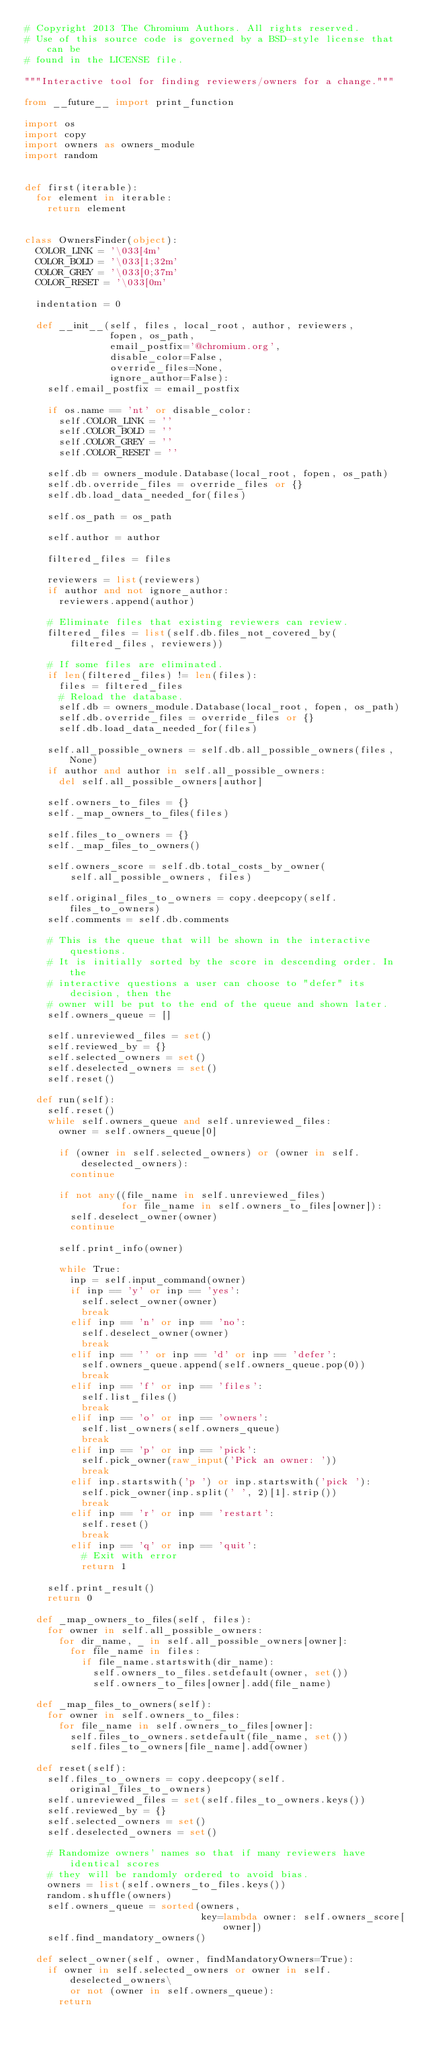Convert code to text. <code><loc_0><loc_0><loc_500><loc_500><_Python_># Copyright 2013 The Chromium Authors. All rights reserved.
# Use of this source code is governed by a BSD-style license that can be
# found in the LICENSE file.

"""Interactive tool for finding reviewers/owners for a change."""

from __future__ import print_function

import os
import copy
import owners as owners_module
import random


def first(iterable):
  for element in iterable:
    return element


class OwnersFinder(object):
  COLOR_LINK = '\033[4m'
  COLOR_BOLD = '\033[1;32m'
  COLOR_GREY = '\033[0;37m'
  COLOR_RESET = '\033[0m'

  indentation = 0

  def __init__(self, files, local_root, author, reviewers,
               fopen, os_path,
               email_postfix='@chromium.org',
               disable_color=False,
               override_files=None,
               ignore_author=False):
    self.email_postfix = email_postfix

    if os.name == 'nt' or disable_color:
      self.COLOR_LINK = ''
      self.COLOR_BOLD = ''
      self.COLOR_GREY = ''
      self.COLOR_RESET = ''

    self.db = owners_module.Database(local_root, fopen, os_path)
    self.db.override_files = override_files or {}
    self.db.load_data_needed_for(files)

    self.os_path = os_path

    self.author = author

    filtered_files = files

    reviewers = list(reviewers)
    if author and not ignore_author:
      reviewers.append(author)

    # Eliminate files that existing reviewers can review.
    filtered_files = list(self.db.files_not_covered_by(
        filtered_files, reviewers))

    # If some files are eliminated.
    if len(filtered_files) != len(files):
      files = filtered_files
      # Reload the database.
      self.db = owners_module.Database(local_root, fopen, os_path)
      self.db.override_files = override_files or {}
      self.db.load_data_needed_for(files)

    self.all_possible_owners = self.db.all_possible_owners(files, None)
    if author and author in self.all_possible_owners:
      del self.all_possible_owners[author]

    self.owners_to_files = {}
    self._map_owners_to_files(files)

    self.files_to_owners = {}
    self._map_files_to_owners()

    self.owners_score = self.db.total_costs_by_owner(
        self.all_possible_owners, files)

    self.original_files_to_owners = copy.deepcopy(self.files_to_owners)
    self.comments = self.db.comments

    # This is the queue that will be shown in the interactive questions.
    # It is initially sorted by the score in descending order. In the
    # interactive questions a user can choose to "defer" its decision, then the
    # owner will be put to the end of the queue and shown later.
    self.owners_queue = []

    self.unreviewed_files = set()
    self.reviewed_by = {}
    self.selected_owners = set()
    self.deselected_owners = set()
    self.reset()

  def run(self):
    self.reset()
    while self.owners_queue and self.unreviewed_files:
      owner = self.owners_queue[0]

      if (owner in self.selected_owners) or (owner in self.deselected_owners):
        continue

      if not any((file_name in self.unreviewed_files)
                 for file_name in self.owners_to_files[owner]):
        self.deselect_owner(owner)
        continue

      self.print_info(owner)

      while True:
        inp = self.input_command(owner)
        if inp == 'y' or inp == 'yes':
          self.select_owner(owner)
          break
        elif inp == 'n' or inp == 'no':
          self.deselect_owner(owner)
          break
        elif inp == '' or inp == 'd' or inp == 'defer':
          self.owners_queue.append(self.owners_queue.pop(0))
          break
        elif inp == 'f' or inp == 'files':
          self.list_files()
          break
        elif inp == 'o' or inp == 'owners':
          self.list_owners(self.owners_queue)
          break
        elif inp == 'p' or inp == 'pick':
          self.pick_owner(raw_input('Pick an owner: '))
          break
        elif inp.startswith('p ') or inp.startswith('pick '):
          self.pick_owner(inp.split(' ', 2)[1].strip())
          break
        elif inp == 'r' or inp == 'restart':
          self.reset()
          break
        elif inp == 'q' or inp == 'quit':
          # Exit with error
          return 1

    self.print_result()
    return 0

  def _map_owners_to_files(self, files):
    for owner in self.all_possible_owners:
      for dir_name, _ in self.all_possible_owners[owner]:
        for file_name in files:
          if file_name.startswith(dir_name):
            self.owners_to_files.setdefault(owner, set())
            self.owners_to_files[owner].add(file_name)

  def _map_files_to_owners(self):
    for owner in self.owners_to_files:
      for file_name in self.owners_to_files[owner]:
        self.files_to_owners.setdefault(file_name, set())
        self.files_to_owners[file_name].add(owner)

  def reset(self):
    self.files_to_owners = copy.deepcopy(self.original_files_to_owners)
    self.unreviewed_files = set(self.files_to_owners.keys())
    self.reviewed_by = {}
    self.selected_owners = set()
    self.deselected_owners = set()

    # Randomize owners' names so that if many reviewers have identical scores
    # they will be randomly ordered to avoid bias.
    owners = list(self.owners_to_files.keys())
    random.shuffle(owners)
    self.owners_queue = sorted(owners,
                               key=lambda owner: self.owners_score[owner])
    self.find_mandatory_owners()

  def select_owner(self, owner, findMandatoryOwners=True):
    if owner in self.selected_owners or owner in self.deselected_owners\
        or not (owner in self.owners_queue):
      return</code> 